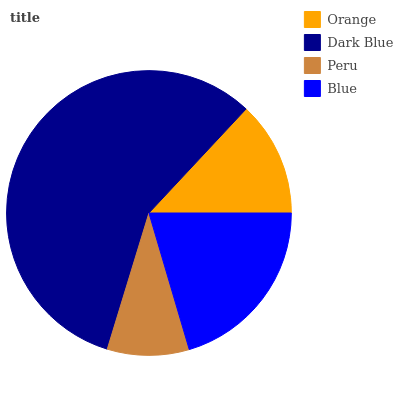Is Peru the minimum?
Answer yes or no. Yes. Is Dark Blue the maximum?
Answer yes or no. Yes. Is Dark Blue the minimum?
Answer yes or no. No. Is Peru the maximum?
Answer yes or no. No. Is Dark Blue greater than Peru?
Answer yes or no. Yes. Is Peru less than Dark Blue?
Answer yes or no. Yes. Is Peru greater than Dark Blue?
Answer yes or no. No. Is Dark Blue less than Peru?
Answer yes or no. No. Is Blue the high median?
Answer yes or no. Yes. Is Orange the low median?
Answer yes or no. Yes. Is Peru the high median?
Answer yes or no. No. Is Dark Blue the low median?
Answer yes or no. No. 